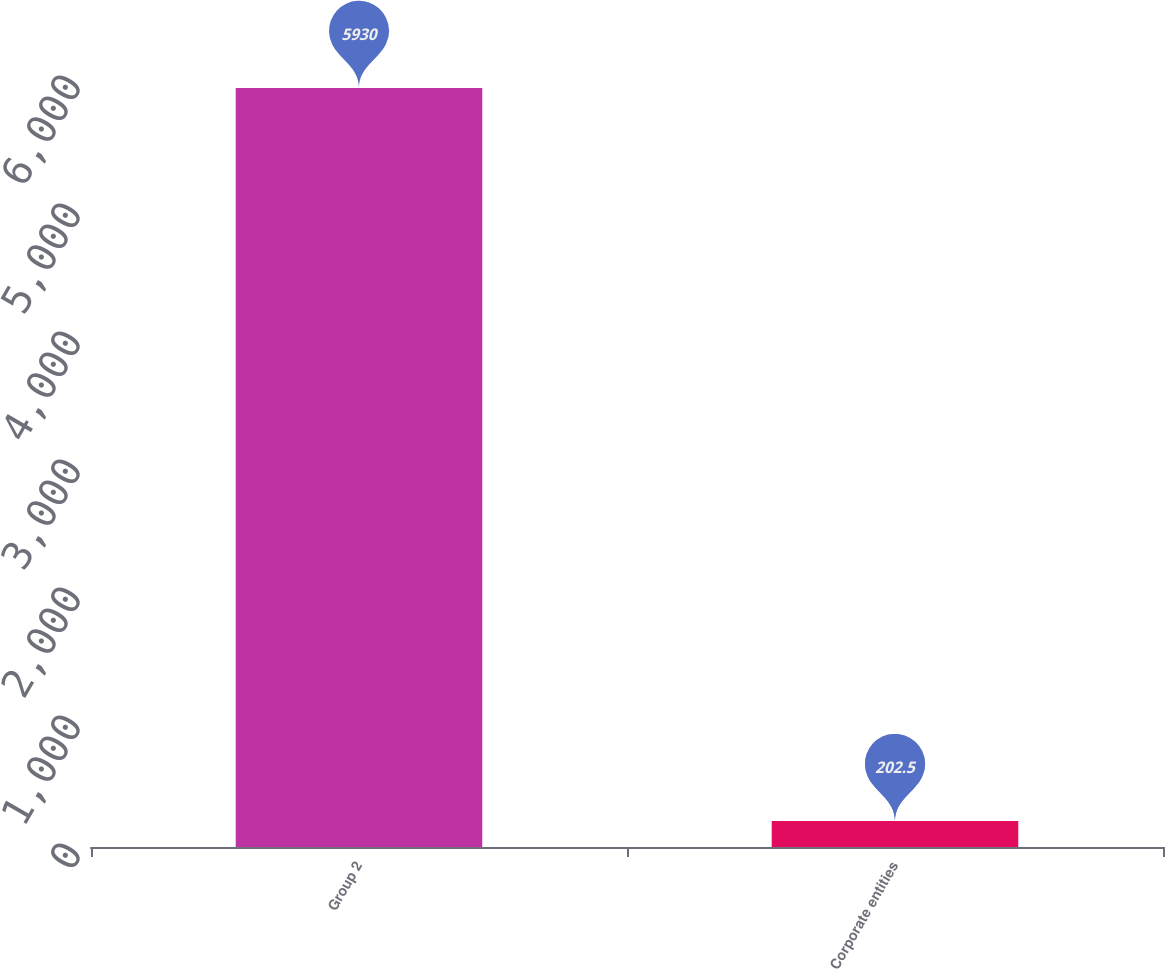<chart> <loc_0><loc_0><loc_500><loc_500><bar_chart><fcel>Group 2<fcel>Corporate entities<nl><fcel>5930<fcel>202.5<nl></chart> 